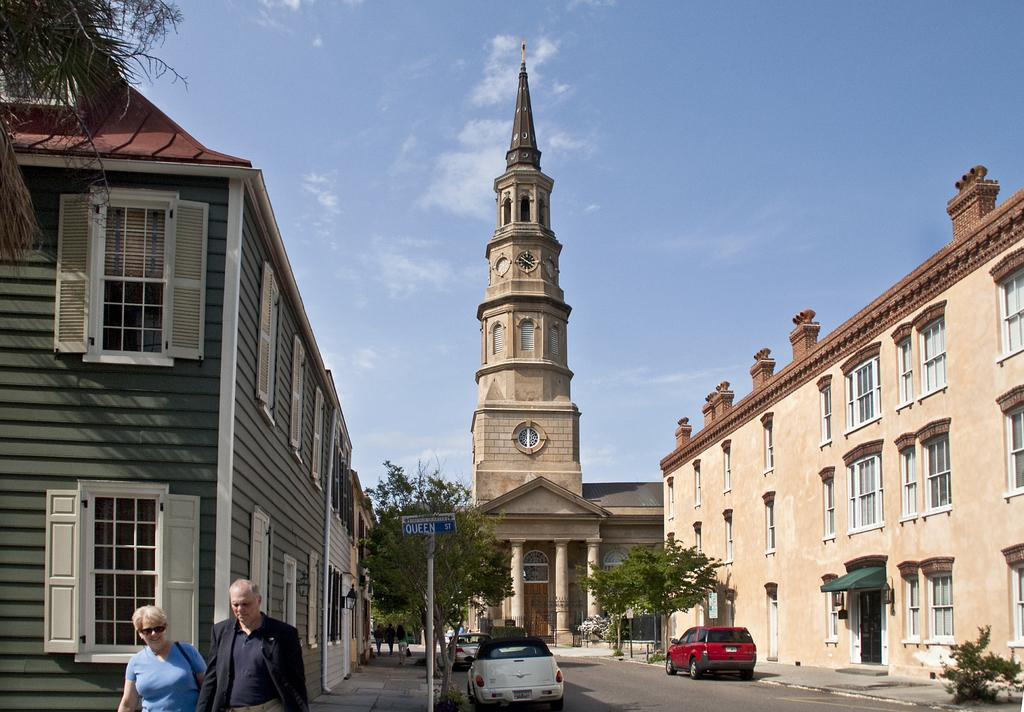What type of structures can be seen in the image? There are buildings in the image. What other natural elements are present in the image? There are trees in the image. What mode of transportation can be seen on the road in the image? There are vehicles on the road in the image. Are there any living beings present in the image? Yes, people are present in the image. What are the vertical structures in the image used for? There are poles in the image, which are likely used for supporting wires or signs. What can be seen in the background of the image? The sky is visible in the background of the image. What type of beef is being served at the restaurant in the image? There is no restaurant or beef present in the image. Can you tell me how many vases are on the table in the image? There are no vases present in the image. 